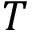<formula> <loc_0><loc_0><loc_500><loc_500>T</formula> 